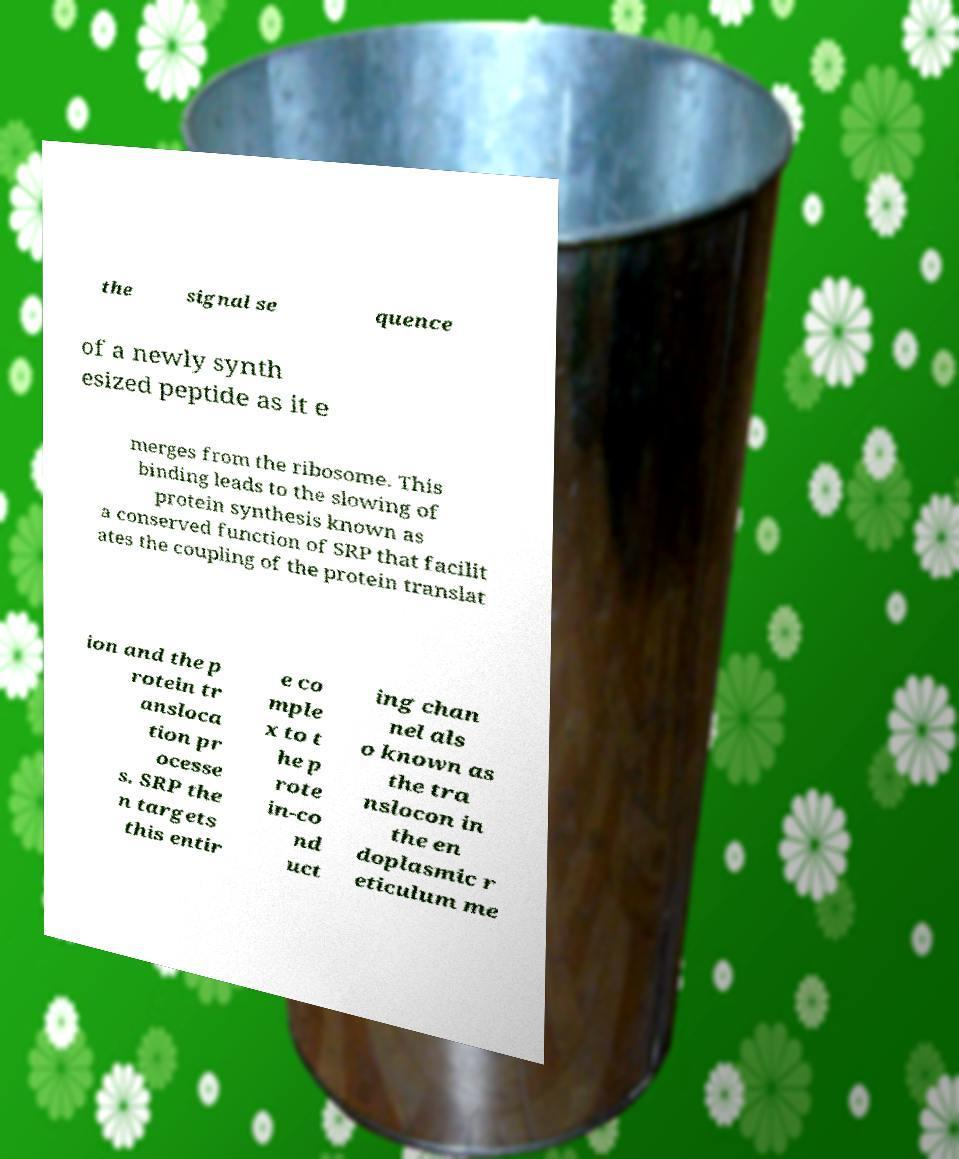Please identify and transcribe the text found in this image. the signal se quence of a newly synth esized peptide as it e merges from the ribosome. This binding leads to the slowing of protein synthesis known as a conserved function of SRP that facilit ates the coupling of the protein translat ion and the p rotein tr ansloca tion pr ocesse s. SRP the n targets this entir e co mple x to t he p rote in-co nd uct ing chan nel als o known as the tra nslocon in the en doplasmic r eticulum me 